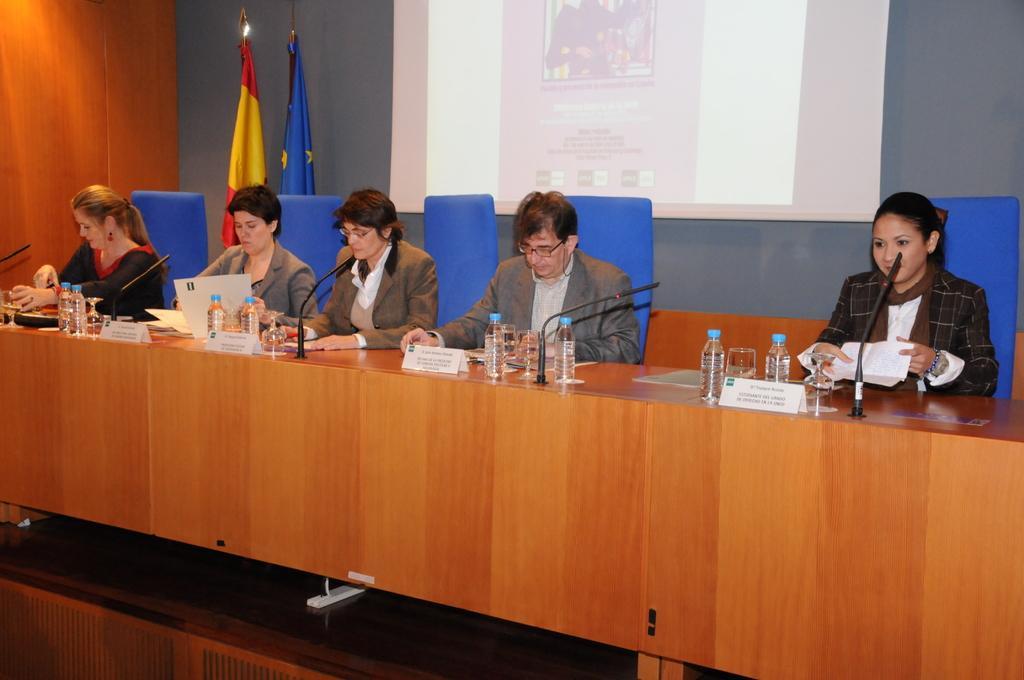Could you give a brief overview of what you see in this image? this picture shows few people seated on the chairs and we see few water bottles ,glasses,and micro phones on the table and we see two flags on the side 